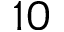Convert formula to latex. <formula><loc_0><loc_0><loc_500><loc_500>1 0</formula> 